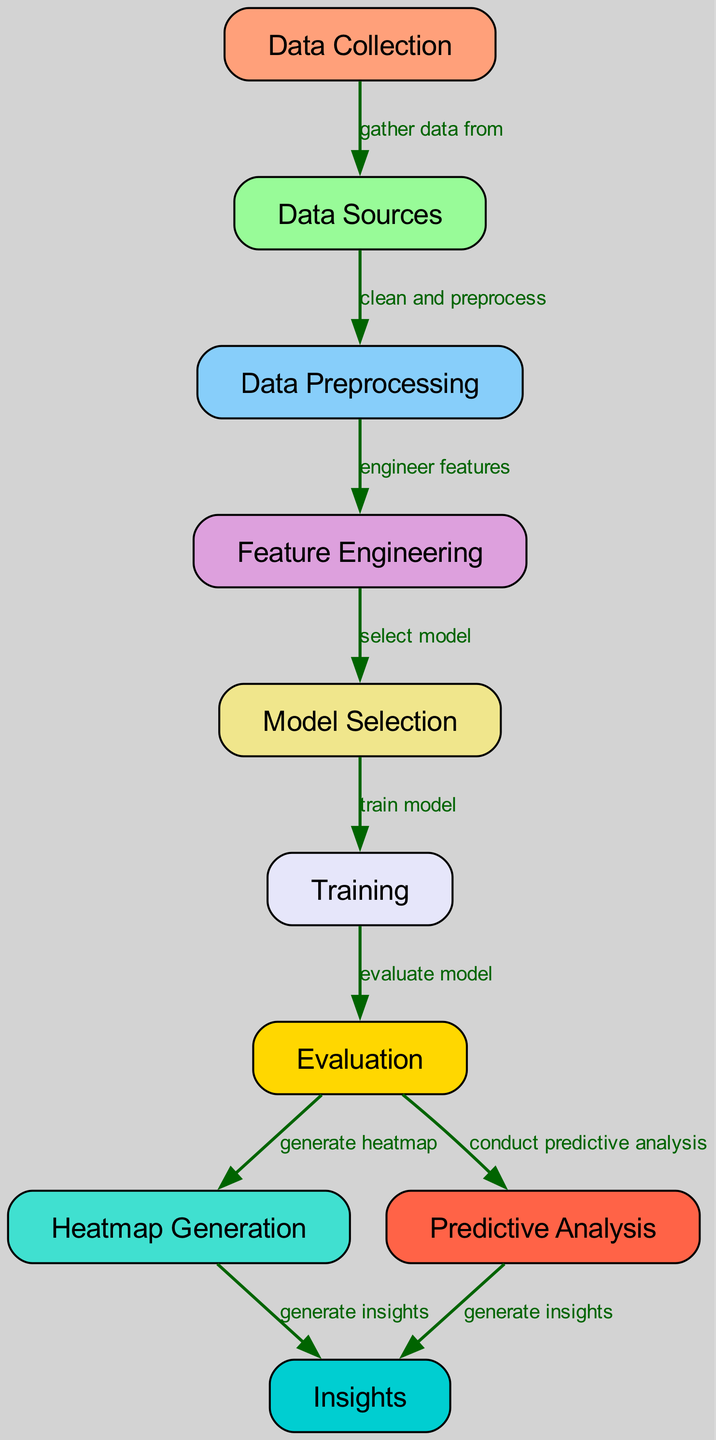What is the first node in the diagram? The first node listed in the diagram is "Data Collection," as it is at the top of the flow and the starting point for the process.
Answer: Data Collection How many total nodes are present in the diagram? By counting the nodes listed, there are ten nodes that represent different stages in the machine learning process.
Answer: 10 Which node follows "Data Sources"? The node that follows "Data Sources" is "Data Preprocessing," indicating the next step after gathering the necessary data sources.
Answer: Data Preprocessing What action is taken from the "Evaluation" node? From the "Evaluation" node, actions are taken to both "generate heatmap" and "conduct predictive analysis," indicating two possible outputs from this evaluation stage.
Answer: Generate heatmap and conduct predictive analysis What type of insights are generated at the end of the diagram? The final output from both "Heatmap Generation" and "Predictive Analysis" is "Insights," blending conclusions from the analysis and visualizations.
Answer: Insights Which two nodes are connected directly after "Training"? After "Training," the two directly connected nodes are "Evaluation" and "Heatmap Generation," showing the immediate follow-up steps after model training.
Answer: Evaluation and Heatmap Generation What is the relationship between "Feature Engineering" and "Model Selection"? The relationship is that "Feature Engineering" leads to "Model Selection," indicating that features must first be engineered before a suitable model can be selected.
Answer: Feature Engineering leads to Model Selection Which process generates insights from the heatmap? The process that generates insights from the heatmap is "Heatmap Generation," as indicated by the directed edge leading to "Insights" from this node.
Answer: Heatmap Generation How many edges are in the diagram? Counting the edges connecting the nodes, there are nine edges in total that describe the flow of data and processes.
Answer: 9 